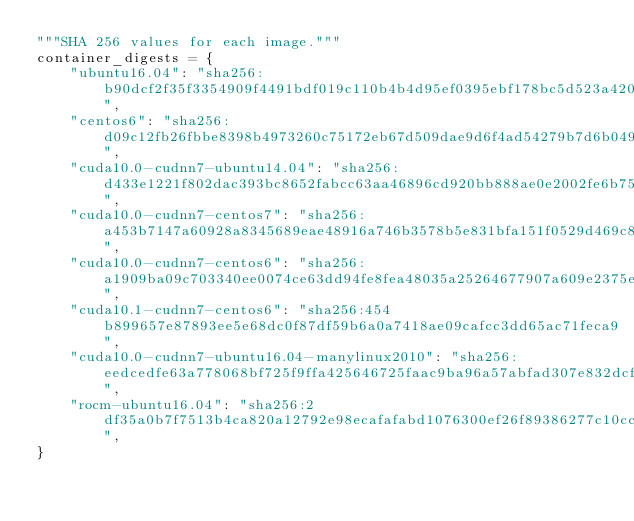Convert code to text. <code><loc_0><loc_0><loc_500><loc_500><_Python_>"""SHA 256 values for each image."""
container_digests = {
    "ubuntu16.04": "sha256:b90dcf2f35f3354909f4491bdf019c110b4b4d95ef0395ebf178bc5d523a4208",
    "centos6": "sha256:d09c12fb26fbbe8398b4973260c75172eb67d509dae9d6f4ad54279b7d6b0494",
    "cuda10.0-cudnn7-ubuntu14.04": "sha256:d433e1221f802dac393bc8652fabcc63aa46896cd920bb888ae0e2002fe6b756",
    "cuda10.0-cudnn7-centos7": "sha256:a453b7147a60928a8345689eae48916a746b3578b5e831bfa151f0529d469c88",
    "cuda10.0-cudnn7-centos6": "sha256:a1909ba09c703340ee0074ce63dd94fe8fea48035a25264677907a609e2375e0",
    "cuda10.1-cudnn7-centos6": "sha256:454b899657e87893ee5e68dc0f87df59b6a0a7418ae09cafcc3dd65ac71feca9",
    "cuda10.0-cudnn7-ubuntu16.04-manylinux2010": "sha256:eedcedfe63a778068bf725f9ffa425646725faac9ba96a57abfad307e832dcf9",
    "rocm-ubuntu16.04": "sha256:2df35a0b7f7513b4ca820a12792e98ecafafabd1076300ef26f89386277c10cc",
}
</code> 